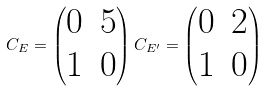<formula> <loc_0><loc_0><loc_500><loc_500>C _ { E } = \begin{pmatrix} 0 & 5 \\ 1 & 0 \end{pmatrix} C _ { E ^ { \prime } } = \begin{pmatrix} 0 & 2 \\ 1 & 0 \end{pmatrix}</formula> 